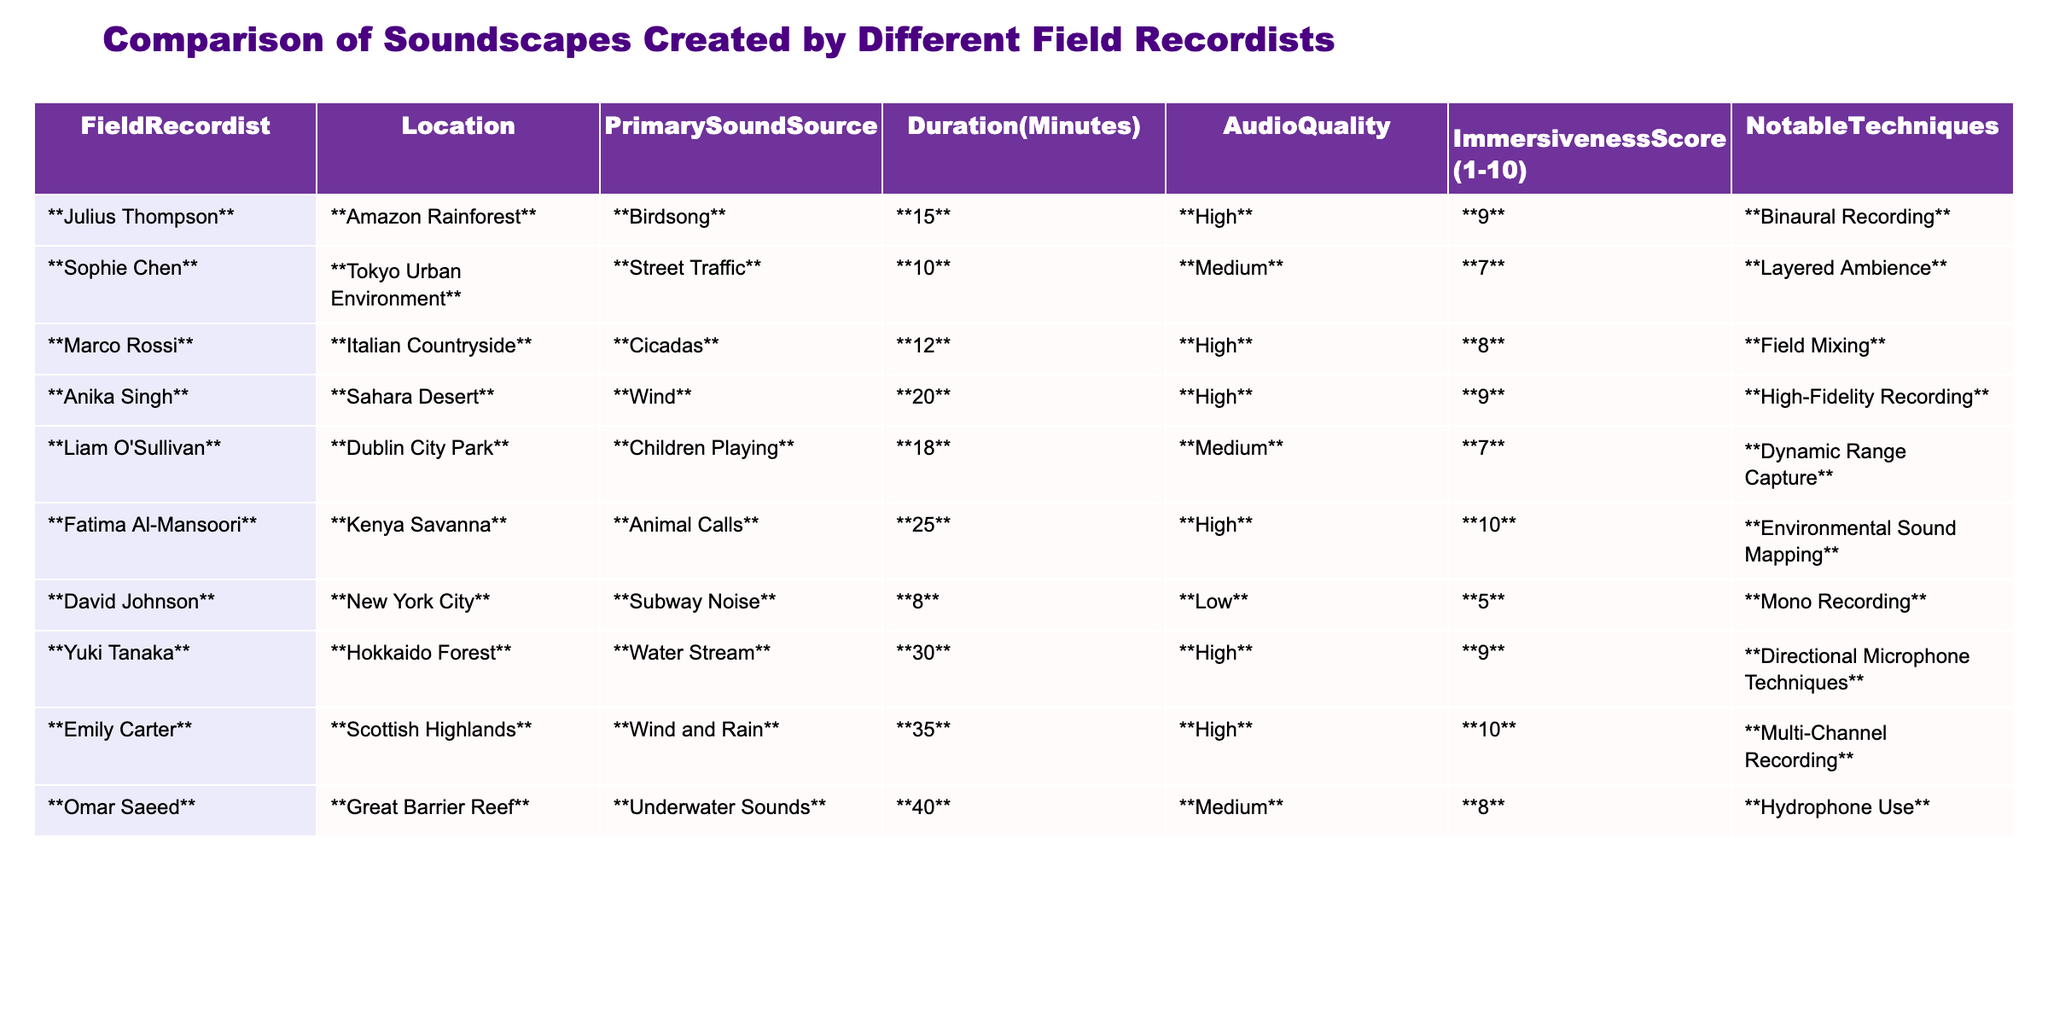What is the primary sound source recorded by Fatima Al-Mansoori? By looking at the entry for Fatima Al-Mansoori in the table, we see that her primary sound source is listed as "Animal Calls."
Answer: Animal Calls Which field recordist has the highest immersiveness score? Fatima Al-Mansoori has the highest immersiveness score of 10, as indicated in her entry in the table.
Answer: Fatima Al-Mansoori How many minutes of audio did Yuki Tanaka record? The table shows that Yuki Tanaka recorded for 30 minutes, as noted in his entry under the Duration column.
Answer: 30 minutes What is the average immersiveness score of all the field recordists? To find the average, we sum all the immersiveness scores: 9 + 7 + 8 + 9 + 7 + 10 + 5 + 9 + 10 + 8 = 82. There are 10 recordists, so the average is 82/10 = 8.2.
Answer: 8.2 True or False: Liam O'Sullivan achieved an audio quality rating of High. Referring to the table, Liam O'Sullivan's audio quality is rated as Medium, which makes this statement false.
Answer: False Which location had the longest recorded duration and what was the primary sound source? The longest recorded duration is 40 minutes by Omar Saeed, and the primary sound source is "Underwater Sounds," as indicated in his entry.
Answer: Great Barrier Reef; Underwater Sounds What notable technique was used by Marco Rossi? According to the table, Marco Rossi utilized "Field Mixing" as his notable technique.
Answer: Field Mixing Count how many field recordists achieved an immersiveness score of 9 or higher. The recordists with an immersiveness score of 9 or higher are Julius Thompson, Anika Singh, Fatima Al-Mansoori, Yuki Tanaka, Emily Carter. This gives a total of 5 recordists.
Answer: 5 What sound source is associated with the Japanese field recordist? Yuki Tanaka, the Japanese field recordist, is associated with the sound source "Water Stream," as shown in the table.
Answer: Water Stream Is there any recordist who used both high audio quality and received a score of 10 for immersiveness? A review of the table reveals that both Emily Carter and Fatima Al-Mansoori have high audio quality and an immersiveness score of 10, confirming the statement is true.
Answer: True 